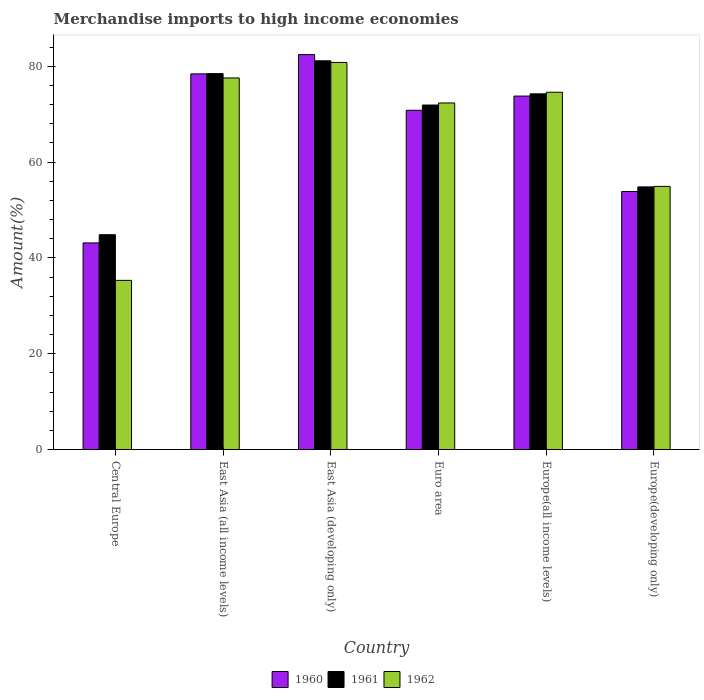How many groups of bars are there?
Your answer should be compact. 6. Are the number of bars per tick equal to the number of legend labels?
Make the answer very short. Yes. Are the number of bars on each tick of the X-axis equal?
Provide a short and direct response. Yes. What is the label of the 5th group of bars from the left?
Offer a terse response. Europe(all income levels). In how many cases, is the number of bars for a given country not equal to the number of legend labels?
Ensure brevity in your answer.  0. What is the percentage of amount earned from merchandise imports in 1960 in Europe(developing only)?
Give a very brief answer. 53.86. Across all countries, what is the maximum percentage of amount earned from merchandise imports in 1962?
Your answer should be very brief. 80.8. Across all countries, what is the minimum percentage of amount earned from merchandise imports in 1962?
Make the answer very short. 35.31. In which country was the percentage of amount earned from merchandise imports in 1962 maximum?
Provide a succinct answer. East Asia (developing only). In which country was the percentage of amount earned from merchandise imports in 1961 minimum?
Ensure brevity in your answer.  Central Europe. What is the total percentage of amount earned from merchandise imports in 1961 in the graph?
Make the answer very short. 405.44. What is the difference between the percentage of amount earned from merchandise imports in 1960 in East Asia (all income levels) and that in East Asia (developing only)?
Your answer should be compact. -4.02. What is the difference between the percentage of amount earned from merchandise imports in 1962 in East Asia (all income levels) and the percentage of amount earned from merchandise imports in 1960 in Europe(all income levels)?
Offer a terse response. 3.78. What is the average percentage of amount earned from merchandise imports in 1960 per country?
Your response must be concise. 67.07. What is the difference between the percentage of amount earned from merchandise imports of/in 1961 and percentage of amount earned from merchandise imports of/in 1960 in Europe(developing only)?
Ensure brevity in your answer.  0.96. What is the ratio of the percentage of amount earned from merchandise imports in 1961 in East Asia (all income levels) to that in Euro area?
Offer a terse response. 1.09. What is the difference between the highest and the second highest percentage of amount earned from merchandise imports in 1960?
Ensure brevity in your answer.  -8.65. What is the difference between the highest and the lowest percentage of amount earned from merchandise imports in 1962?
Make the answer very short. 45.49. What does the 2nd bar from the left in East Asia (all income levels) represents?
Provide a short and direct response. 1961. What does the 3rd bar from the right in East Asia (developing only) represents?
Offer a terse response. 1960. Is it the case that in every country, the sum of the percentage of amount earned from merchandise imports in 1962 and percentage of amount earned from merchandise imports in 1961 is greater than the percentage of amount earned from merchandise imports in 1960?
Offer a very short reply. Yes. Are all the bars in the graph horizontal?
Give a very brief answer. No. Are the values on the major ticks of Y-axis written in scientific E-notation?
Your answer should be compact. No. Does the graph contain any zero values?
Your answer should be compact. No. Does the graph contain grids?
Offer a terse response. No. Where does the legend appear in the graph?
Offer a very short reply. Bottom center. How many legend labels are there?
Ensure brevity in your answer.  3. How are the legend labels stacked?
Provide a short and direct response. Horizontal. What is the title of the graph?
Make the answer very short. Merchandise imports to high income economies. Does "1985" appear as one of the legend labels in the graph?
Give a very brief answer. No. What is the label or title of the X-axis?
Offer a terse response. Country. What is the label or title of the Y-axis?
Give a very brief answer. Amount(%). What is the Amount(%) in 1960 in Central Europe?
Keep it short and to the point. 43.13. What is the Amount(%) in 1961 in Central Europe?
Keep it short and to the point. 44.84. What is the Amount(%) of 1962 in Central Europe?
Give a very brief answer. 35.31. What is the Amount(%) of 1960 in East Asia (all income levels)?
Your answer should be very brief. 78.41. What is the Amount(%) of 1961 in East Asia (all income levels)?
Keep it short and to the point. 78.47. What is the Amount(%) of 1962 in East Asia (all income levels)?
Your answer should be very brief. 77.56. What is the Amount(%) in 1960 in East Asia (developing only)?
Ensure brevity in your answer.  82.44. What is the Amount(%) of 1961 in East Asia (developing only)?
Offer a terse response. 81.14. What is the Amount(%) in 1962 in East Asia (developing only)?
Ensure brevity in your answer.  80.8. What is the Amount(%) of 1960 in Euro area?
Offer a terse response. 70.81. What is the Amount(%) of 1961 in Euro area?
Your answer should be compact. 71.91. What is the Amount(%) in 1962 in Euro area?
Your answer should be very brief. 72.34. What is the Amount(%) of 1960 in Europe(all income levels)?
Offer a terse response. 73.78. What is the Amount(%) of 1961 in Europe(all income levels)?
Provide a short and direct response. 74.25. What is the Amount(%) of 1962 in Europe(all income levels)?
Ensure brevity in your answer.  74.58. What is the Amount(%) in 1960 in Europe(developing only)?
Offer a terse response. 53.86. What is the Amount(%) in 1961 in Europe(developing only)?
Ensure brevity in your answer.  54.82. What is the Amount(%) in 1962 in Europe(developing only)?
Your answer should be very brief. 54.93. Across all countries, what is the maximum Amount(%) in 1960?
Offer a terse response. 82.44. Across all countries, what is the maximum Amount(%) of 1961?
Keep it short and to the point. 81.14. Across all countries, what is the maximum Amount(%) in 1962?
Give a very brief answer. 80.8. Across all countries, what is the minimum Amount(%) of 1960?
Offer a terse response. 43.13. Across all countries, what is the minimum Amount(%) of 1961?
Keep it short and to the point. 44.84. Across all countries, what is the minimum Amount(%) of 1962?
Provide a succinct answer. 35.31. What is the total Amount(%) of 1960 in the graph?
Provide a succinct answer. 402.44. What is the total Amount(%) in 1961 in the graph?
Your answer should be compact. 405.44. What is the total Amount(%) in 1962 in the graph?
Your answer should be compact. 395.52. What is the difference between the Amount(%) of 1960 in Central Europe and that in East Asia (all income levels)?
Provide a succinct answer. -35.28. What is the difference between the Amount(%) in 1961 in Central Europe and that in East Asia (all income levels)?
Your answer should be very brief. -33.63. What is the difference between the Amount(%) in 1962 in Central Europe and that in East Asia (all income levels)?
Ensure brevity in your answer.  -42.25. What is the difference between the Amount(%) of 1960 in Central Europe and that in East Asia (developing only)?
Make the answer very short. -39.31. What is the difference between the Amount(%) of 1961 in Central Europe and that in East Asia (developing only)?
Keep it short and to the point. -36.3. What is the difference between the Amount(%) of 1962 in Central Europe and that in East Asia (developing only)?
Offer a very short reply. -45.49. What is the difference between the Amount(%) of 1960 in Central Europe and that in Euro area?
Your response must be concise. -27.69. What is the difference between the Amount(%) of 1961 in Central Europe and that in Euro area?
Provide a short and direct response. -27.07. What is the difference between the Amount(%) of 1962 in Central Europe and that in Euro area?
Provide a succinct answer. -37.03. What is the difference between the Amount(%) of 1960 in Central Europe and that in Europe(all income levels)?
Your answer should be compact. -30.65. What is the difference between the Amount(%) of 1961 in Central Europe and that in Europe(all income levels)?
Offer a terse response. -29.41. What is the difference between the Amount(%) in 1962 in Central Europe and that in Europe(all income levels)?
Provide a short and direct response. -39.27. What is the difference between the Amount(%) in 1960 in Central Europe and that in Europe(developing only)?
Offer a very short reply. -10.73. What is the difference between the Amount(%) of 1961 in Central Europe and that in Europe(developing only)?
Provide a succinct answer. -9.98. What is the difference between the Amount(%) in 1962 in Central Europe and that in Europe(developing only)?
Ensure brevity in your answer.  -19.61. What is the difference between the Amount(%) of 1960 in East Asia (all income levels) and that in East Asia (developing only)?
Your response must be concise. -4.02. What is the difference between the Amount(%) in 1961 in East Asia (all income levels) and that in East Asia (developing only)?
Make the answer very short. -2.67. What is the difference between the Amount(%) of 1962 in East Asia (all income levels) and that in East Asia (developing only)?
Ensure brevity in your answer.  -3.24. What is the difference between the Amount(%) of 1960 in East Asia (all income levels) and that in Euro area?
Give a very brief answer. 7.6. What is the difference between the Amount(%) of 1961 in East Asia (all income levels) and that in Euro area?
Your answer should be very brief. 6.56. What is the difference between the Amount(%) in 1962 in East Asia (all income levels) and that in Euro area?
Provide a succinct answer. 5.22. What is the difference between the Amount(%) of 1960 in East Asia (all income levels) and that in Europe(all income levels)?
Your answer should be compact. 4.63. What is the difference between the Amount(%) of 1961 in East Asia (all income levels) and that in Europe(all income levels)?
Your response must be concise. 4.22. What is the difference between the Amount(%) of 1962 in East Asia (all income levels) and that in Europe(all income levels)?
Provide a succinct answer. 2.98. What is the difference between the Amount(%) of 1960 in East Asia (all income levels) and that in Europe(developing only)?
Offer a terse response. 24.55. What is the difference between the Amount(%) in 1961 in East Asia (all income levels) and that in Europe(developing only)?
Your answer should be very brief. 23.65. What is the difference between the Amount(%) of 1962 in East Asia (all income levels) and that in Europe(developing only)?
Offer a terse response. 22.64. What is the difference between the Amount(%) in 1960 in East Asia (developing only) and that in Euro area?
Make the answer very short. 11.62. What is the difference between the Amount(%) in 1961 in East Asia (developing only) and that in Euro area?
Your response must be concise. 9.23. What is the difference between the Amount(%) of 1962 in East Asia (developing only) and that in Euro area?
Ensure brevity in your answer.  8.46. What is the difference between the Amount(%) of 1960 in East Asia (developing only) and that in Europe(all income levels)?
Ensure brevity in your answer.  8.65. What is the difference between the Amount(%) in 1961 in East Asia (developing only) and that in Europe(all income levels)?
Keep it short and to the point. 6.89. What is the difference between the Amount(%) in 1962 in East Asia (developing only) and that in Europe(all income levels)?
Offer a terse response. 6.22. What is the difference between the Amount(%) in 1960 in East Asia (developing only) and that in Europe(developing only)?
Provide a succinct answer. 28.57. What is the difference between the Amount(%) in 1961 in East Asia (developing only) and that in Europe(developing only)?
Your answer should be very brief. 26.32. What is the difference between the Amount(%) of 1962 in East Asia (developing only) and that in Europe(developing only)?
Provide a short and direct response. 25.88. What is the difference between the Amount(%) in 1960 in Euro area and that in Europe(all income levels)?
Provide a succinct answer. -2.97. What is the difference between the Amount(%) of 1961 in Euro area and that in Europe(all income levels)?
Ensure brevity in your answer.  -2.33. What is the difference between the Amount(%) in 1962 in Euro area and that in Europe(all income levels)?
Ensure brevity in your answer.  -2.24. What is the difference between the Amount(%) of 1960 in Euro area and that in Europe(developing only)?
Provide a short and direct response. 16.95. What is the difference between the Amount(%) in 1961 in Euro area and that in Europe(developing only)?
Provide a succinct answer. 17.09. What is the difference between the Amount(%) in 1962 in Euro area and that in Europe(developing only)?
Your response must be concise. 17.42. What is the difference between the Amount(%) in 1960 in Europe(all income levels) and that in Europe(developing only)?
Ensure brevity in your answer.  19.92. What is the difference between the Amount(%) of 1961 in Europe(all income levels) and that in Europe(developing only)?
Provide a succinct answer. 19.42. What is the difference between the Amount(%) of 1962 in Europe(all income levels) and that in Europe(developing only)?
Your answer should be very brief. 19.66. What is the difference between the Amount(%) of 1960 in Central Europe and the Amount(%) of 1961 in East Asia (all income levels)?
Offer a very short reply. -35.34. What is the difference between the Amount(%) in 1960 in Central Europe and the Amount(%) in 1962 in East Asia (all income levels)?
Ensure brevity in your answer.  -34.43. What is the difference between the Amount(%) of 1961 in Central Europe and the Amount(%) of 1962 in East Asia (all income levels)?
Provide a succinct answer. -32.72. What is the difference between the Amount(%) in 1960 in Central Europe and the Amount(%) in 1961 in East Asia (developing only)?
Your answer should be very brief. -38.01. What is the difference between the Amount(%) in 1960 in Central Europe and the Amount(%) in 1962 in East Asia (developing only)?
Make the answer very short. -37.67. What is the difference between the Amount(%) in 1961 in Central Europe and the Amount(%) in 1962 in East Asia (developing only)?
Ensure brevity in your answer.  -35.96. What is the difference between the Amount(%) in 1960 in Central Europe and the Amount(%) in 1961 in Euro area?
Offer a very short reply. -28.78. What is the difference between the Amount(%) in 1960 in Central Europe and the Amount(%) in 1962 in Euro area?
Provide a short and direct response. -29.21. What is the difference between the Amount(%) of 1961 in Central Europe and the Amount(%) of 1962 in Euro area?
Make the answer very short. -27.5. What is the difference between the Amount(%) of 1960 in Central Europe and the Amount(%) of 1961 in Europe(all income levels)?
Offer a very short reply. -31.12. What is the difference between the Amount(%) of 1960 in Central Europe and the Amount(%) of 1962 in Europe(all income levels)?
Offer a terse response. -31.45. What is the difference between the Amount(%) of 1961 in Central Europe and the Amount(%) of 1962 in Europe(all income levels)?
Provide a short and direct response. -29.74. What is the difference between the Amount(%) in 1960 in Central Europe and the Amount(%) in 1961 in Europe(developing only)?
Keep it short and to the point. -11.69. What is the difference between the Amount(%) of 1960 in Central Europe and the Amount(%) of 1962 in Europe(developing only)?
Offer a very short reply. -11.8. What is the difference between the Amount(%) of 1961 in Central Europe and the Amount(%) of 1962 in Europe(developing only)?
Offer a very short reply. -10.08. What is the difference between the Amount(%) in 1960 in East Asia (all income levels) and the Amount(%) in 1961 in East Asia (developing only)?
Your answer should be very brief. -2.73. What is the difference between the Amount(%) in 1960 in East Asia (all income levels) and the Amount(%) in 1962 in East Asia (developing only)?
Provide a short and direct response. -2.39. What is the difference between the Amount(%) of 1961 in East Asia (all income levels) and the Amount(%) of 1962 in East Asia (developing only)?
Your response must be concise. -2.33. What is the difference between the Amount(%) of 1960 in East Asia (all income levels) and the Amount(%) of 1961 in Euro area?
Make the answer very short. 6.5. What is the difference between the Amount(%) in 1960 in East Asia (all income levels) and the Amount(%) in 1962 in Euro area?
Keep it short and to the point. 6.07. What is the difference between the Amount(%) in 1961 in East Asia (all income levels) and the Amount(%) in 1962 in Euro area?
Offer a very short reply. 6.13. What is the difference between the Amount(%) of 1960 in East Asia (all income levels) and the Amount(%) of 1961 in Europe(all income levels)?
Your answer should be very brief. 4.16. What is the difference between the Amount(%) of 1960 in East Asia (all income levels) and the Amount(%) of 1962 in Europe(all income levels)?
Your answer should be very brief. 3.83. What is the difference between the Amount(%) in 1961 in East Asia (all income levels) and the Amount(%) in 1962 in Europe(all income levels)?
Offer a very short reply. 3.89. What is the difference between the Amount(%) of 1960 in East Asia (all income levels) and the Amount(%) of 1961 in Europe(developing only)?
Ensure brevity in your answer.  23.59. What is the difference between the Amount(%) of 1960 in East Asia (all income levels) and the Amount(%) of 1962 in Europe(developing only)?
Your answer should be very brief. 23.49. What is the difference between the Amount(%) in 1961 in East Asia (all income levels) and the Amount(%) in 1962 in Europe(developing only)?
Offer a terse response. 23.55. What is the difference between the Amount(%) of 1960 in East Asia (developing only) and the Amount(%) of 1961 in Euro area?
Your response must be concise. 10.52. What is the difference between the Amount(%) of 1960 in East Asia (developing only) and the Amount(%) of 1962 in Euro area?
Offer a terse response. 10.09. What is the difference between the Amount(%) in 1961 in East Asia (developing only) and the Amount(%) in 1962 in Euro area?
Ensure brevity in your answer.  8.8. What is the difference between the Amount(%) of 1960 in East Asia (developing only) and the Amount(%) of 1961 in Europe(all income levels)?
Your response must be concise. 8.19. What is the difference between the Amount(%) in 1960 in East Asia (developing only) and the Amount(%) in 1962 in Europe(all income levels)?
Give a very brief answer. 7.85. What is the difference between the Amount(%) of 1961 in East Asia (developing only) and the Amount(%) of 1962 in Europe(all income levels)?
Offer a terse response. 6.56. What is the difference between the Amount(%) of 1960 in East Asia (developing only) and the Amount(%) of 1961 in Europe(developing only)?
Your answer should be very brief. 27.61. What is the difference between the Amount(%) in 1960 in East Asia (developing only) and the Amount(%) in 1962 in Europe(developing only)?
Keep it short and to the point. 27.51. What is the difference between the Amount(%) of 1961 in East Asia (developing only) and the Amount(%) of 1962 in Europe(developing only)?
Provide a short and direct response. 26.22. What is the difference between the Amount(%) of 1960 in Euro area and the Amount(%) of 1961 in Europe(all income levels)?
Your answer should be compact. -3.43. What is the difference between the Amount(%) in 1960 in Euro area and the Amount(%) in 1962 in Europe(all income levels)?
Provide a short and direct response. -3.77. What is the difference between the Amount(%) in 1961 in Euro area and the Amount(%) in 1962 in Europe(all income levels)?
Your response must be concise. -2.67. What is the difference between the Amount(%) of 1960 in Euro area and the Amount(%) of 1961 in Europe(developing only)?
Keep it short and to the point. 15.99. What is the difference between the Amount(%) in 1960 in Euro area and the Amount(%) in 1962 in Europe(developing only)?
Provide a short and direct response. 15.89. What is the difference between the Amount(%) of 1961 in Euro area and the Amount(%) of 1962 in Europe(developing only)?
Your response must be concise. 16.99. What is the difference between the Amount(%) of 1960 in Europe(all income levels) and the Amount(%) of 1961 in Europe(developing only)?
Your answer should be very brief. 18.96. What is the difference between the Amount(%) of 1960 in Europe(all income levels) and the Amount(%) of 1962 in Europe(developing only)?
Your answer should be compact. 18.86. What is the difference between the Amount(%) in 1961 in Europe(all income levels) and the Amount(%) in 1962 in Europe(developing only)?
Keep it short and to the point. 19.32. What is the average Amount(%) of 1960 per country?
Provide a succinct answer. 67.07. What is the average Amount(%) of 1961 per country?
Your answer should be very brief. 67.57. What is the average Amount(%) of 1962 per country?
Offer a terse response. 65.92. What is the difference between the Amount(%) of 1960 and Amount(%) of 1961 in Central Europe?
Keep it short and to the point. -1.71. What is the difference between the Amount(%) of 1960 and Amount(%) of 1962 in Central Europe?
Provide a succinct answer. 7.82. What is the difference between the Amount(%) in 1961 and Amount(%) in 1962 in Central Europe?
Give a very brief answer. 9.53. What is the difference between the Amount(%) of 1960 and Amount(%) of 1961 in East Asia (all income levels)?
Provide a succinct answer. -0.06. What is the difference between the Amount(%) of 1960 and Amount(%) of 1962 in East Asia (all income levels)?
Keep it short and to the point. 0.85. What is the difference between the Amount(%) of 1961 and Amount(%) of 1962 in East Asia (all income levels)?
Make the answer very short. 0.91. What is the difference between the Amount(%) of 1960 and Amount(%) of 1961 in East Asia (developing only)?
Your response must be concise. 1.29. What is the difference between the Amount(%) of 1960 and Amount(%) of 1962 in East Asia (developing only)?
Offer a terse response. 1.63. What is the difference between the Amount(%) in 1961 and Amount(%) in 1962 in East Asia (developing only)?
Your response must be concise. 0.34. What is the difference between the Amount(%) in 1960 and Amount(%) in 1961 in Euro area?
Give a very brief answer. -1.1. What is the difference between the Amount(%) in 1960 and Amount(%) in 1962 in Euro area?
Make the answer very short. -1.53. What is the difference between the Amount(%) in 1961 and Amount(%) in 1962 in Euro area?
Give a very brief answer. -0.43. What is the difference between the Amount(%) in 1960 and Amount(%) in 1961 in Europe(all income levels)?
Make the answer very short. -0.47. What is the difference between the Amount(%) of 1960 and Amount(%) of 1962 in Europe(all income levels)?
Keep it short and to the point. -0.8. What is the difference between the Amount(%) of 1961 and Amount(%) of 1962 in Europe(all income levels)?
Make the answer very short. -0.33. What is the difference between the Amount(%) in 1960 and Amount(%) in 1961 in Europe(developing only)?
Provide a succinct answer. -0.96. What is the difference between the Amount(%) of 1960 and Amount(%) of 1962 in Europe(developing only)?
Keep it short and to the point. -1.06. What is the difference between the Amount(%) in 1961 and Amount(%) in 1962 in Europe(developing only)?
Ensure brevity in your answer.  -0.1. What is the ratio of the Amount(%) of 1960 in Central Europe to that in East Asia (all income levels)?
Make the answer very short. 0.55. What is the ratio of the Amount(%) of 1961 in Central Europe to that in East Asia (all income levels)?
Provide a succinct answer. 0.57. What is the ratio of the Amount(%) of 1962 in Central Europe to that in East Asia (all income levels)?
Make the answer very short. 0.46. What is the ratio of the Amount(%) of 1960 in Central Europe to that in East Asia (developing only)?
Provide a succinct answer. 0.52. What is the ratio of the Amount(%) of 1961 in Central Europe to that in East Asia (developing only)?
Offer a terse response. 0.55. What is the ratio of the Amount(%) in 1962 in Central Europe to that in East Asia (developing only)?
Offer a very short reply. 0.44. What is the ratio of the Amount(%) in 1960 in Central Europe to that in Euro area?
Offer a terse response. 0.61. What is the ratio of the Amount(%) in 1961 in Central Europe to that in Euro area?
Your answer should be very brief. 0.62. What is the ratio of the Amount(%) in 1962 in Central Europe to that in Euro area?
Make the answer very short. 0.49. What is the ratio of the Amount(%) in 1960 in Central Europe to that in Europe(all income levels)?
Make the answer very short. 0.58. What is the ratio of the Amount(%) of 1961 in Central Europe to that in Europe(all income levels)?
Ensure brevity in your answer.  0.6. What is the ratio of the Amount(%) in 1962 in Central Europe to that in Europe(all income levels)?
Ensure brevity in your answer.  0.47. What is the ratio of the Amount(%) of 1960 in Central Europe to that in Europe(developing only)?
Your answer should be compact. 0.8. What is the ratio of the Amount(%) of 1961 in Central Europe to that in Europe(developing only)?
Ensure brevity in your answer.  0.82. What is the ratio of the Amount(%) of 1962 in Central Europe to that in Europe(developing only)?
Ensure brevity in your answer.  0.64. What is the ratio of the Amount(%) in 1960 in East Asia (all income levels) to that in East Asia (developing only)?
Your answer should be compact. 0.95. What is the ratio of the Amount(%) of 1961 in East Asia (all income levels) to that in East Asia (developing only)?
Your answer should be very brief. 0.97. What is the ratio of the Amount(%) in 1962 in East Asia (all income levels) to that in East Asia (developing only)?
Offer a terse response. 0.96. What is the ratio of the Amount(%) in 1960 in East Asia (all income levels) to that in Euro area?
Provide a succinct answer. 1.11. What is the ratio of the Amount(%) of 1961 in East Asia (all income levels) to that in Euro area?
Your response must be concise. 1.09. What is the ratio of the Amount(%) of 1962 in East Asia (all income levels) to that in Euro area?
Ensure brevity in your answer.  1.07. What is the ratio of the Amount(%) of 1960 in East Asia (all income levels) to that in Europe(all income levels)?
Provide a succinct answer. 1.06. What is the ratio of the Amount(%) in 1961 in East Asia (all income levels) to that in Europe(all income levels)?
Your answer should be very brief. 1.06. What is the ratio of the Amount(%) in 1962 in East Asia (all income levels) to that in Europe(all income levels)?
Keep it short and to the point. 1.04. What is the ratio of the Amount(%) of 1960 in East Asia (all income levels) to that in Europe(developing only)?
Give a very brief answer. 1.46. What is the ratio of the Amount(%) in 1961 in East Asia (all income levels) to that in Europe(developing only)?
Provide a succinct answer. 1.43. What is the ratio of the Amount(%) of 1962 in East Asia (all income levels) to that in Europe(developing only)?
Offer a very short reply. 1.41. What is the ratio of the Amount(%) of 1960 in East Asia (developing only) to that in Euro area?
Provide a succinct answer. 1.16. What is the ratio of the Amount(%) in 1961 in East Asia (developing only) to that in Euro area?
Ensure brevity in your answer.  1.13. What is the ratio of the Amount(%) in 1962 in East Asia (developing only) to that in Euro area?
Keep it short and to the point. 1.12. What is the ratio of the Amount(%) in 1960 in East Asia (developing only) to that in Europe(all income levels)?
Give a very brief answer. 1.12. What is the ratio of the Amount(%) in 1961 in East Asia (developing only) to that in Europe(all income levels)?
Provide a short and direct response. 1.09. What is the ratio of the Amount(%) in 1962 in East Asia (developing only) to that in Europe(all income levels)?
Ensure brevity in your answer.  1.08. What is the ratio of the Amount(%) of 1960 in East Asia (developing only) to that in Europe(developing only)?
Your response must be concise. 1.53. What is the ratio of the Amount(%) in 1961 in East Asia (developing only) to that in Europe(developing only)?
Keep it short and to the point. 1.48. What is the ratio of the Amount(%) of 1962 in East Asia (developing only) to that in Europe(developing only)?
Your response must be concise. 1.47. What is the ratio of the Amount(%) of 1960 in Euro area to that in Europe(all income levels)?
Make the answer very short. 0.96. What is the ratio of the Amount(%) of 1961 in Euro area to that in Europe(all income levels)?
Provide a short and direct response. 0.97. What is the ratio of the Amount(%) of 1962 in Euro area to that in Europe(all income levels)?
Your answer should be very brief. 0.97. What is the ratio of the Amount(%) of 1960 in Euro area to that in Europe(developing only)?
Your answer should be very brief. 1.31. What is the ratio of the Amount(%) in 1961 in Euro area to that in Europe(developing only)?
Provide a short and direct response. 1.31. What is the ratio of the Amount(%) in 1962 in Euro area to that in Europe(developing only)?
Give a very brief answer. 1.32. What is the ratio of the Amount(%) of 1960 in Europe(all income levels) to that in Europe(developing only)?
Give a very brief answer. 1.37. What is the ratio of the Amount(%) of 1961 in Europe(all income levels) to that in Europe(developing only)?
Your response must be concise. 1.35. What is the ratio of the Amount(%) in 1962 in Europe(all income levels) to that in Europe(developing only)?
Your response must be concise. 1.36. What is the difference between the highest and the second highest Amount(%) of 1960?
Give a very brief answer. 4.02. What is the difference between the highest and the second highest Amount(%) in 1961?
Your answer should be very brief. 2.67. What is the difference between the highest and the second highest Amount(%) of 1962?
Offer a very short reply. 3.24. What is the difference between the highest and the lowest Amount(%) in 1960?
Provide a short and direct response. 39.31. What is the difference between the highest and the lowest Amount(%) in 1961?
Keep it short and to the point. 36.3. What is the difference between the highest and the lowest Amount(%) of 1962?
Provide a short and direct response. 45.49. 